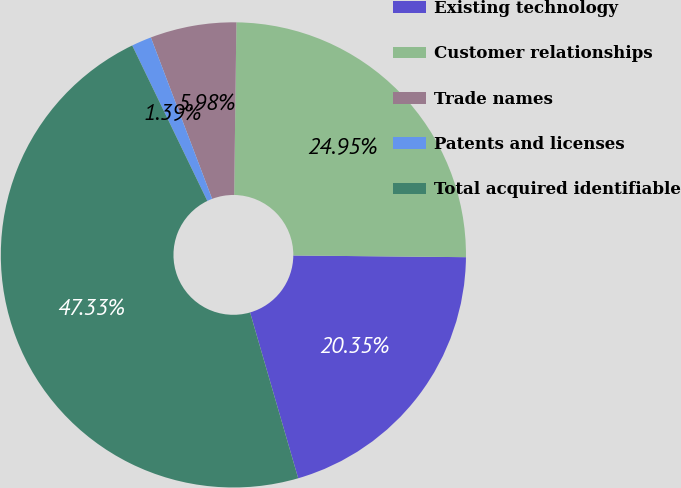<chart> <loc_0><loc_0><loc_500><loc_500><pie_chart><fcel>Existing technology<fcel>Customer relationships<fcel>Trade names<fcel>Patents and licenses<fcel>Total acquired identifiable<nl><fcel>20.35%<fcel>24.95%<fcel>5.98%<fcel>1.39%<fcel>47.33%<nl></chart> 